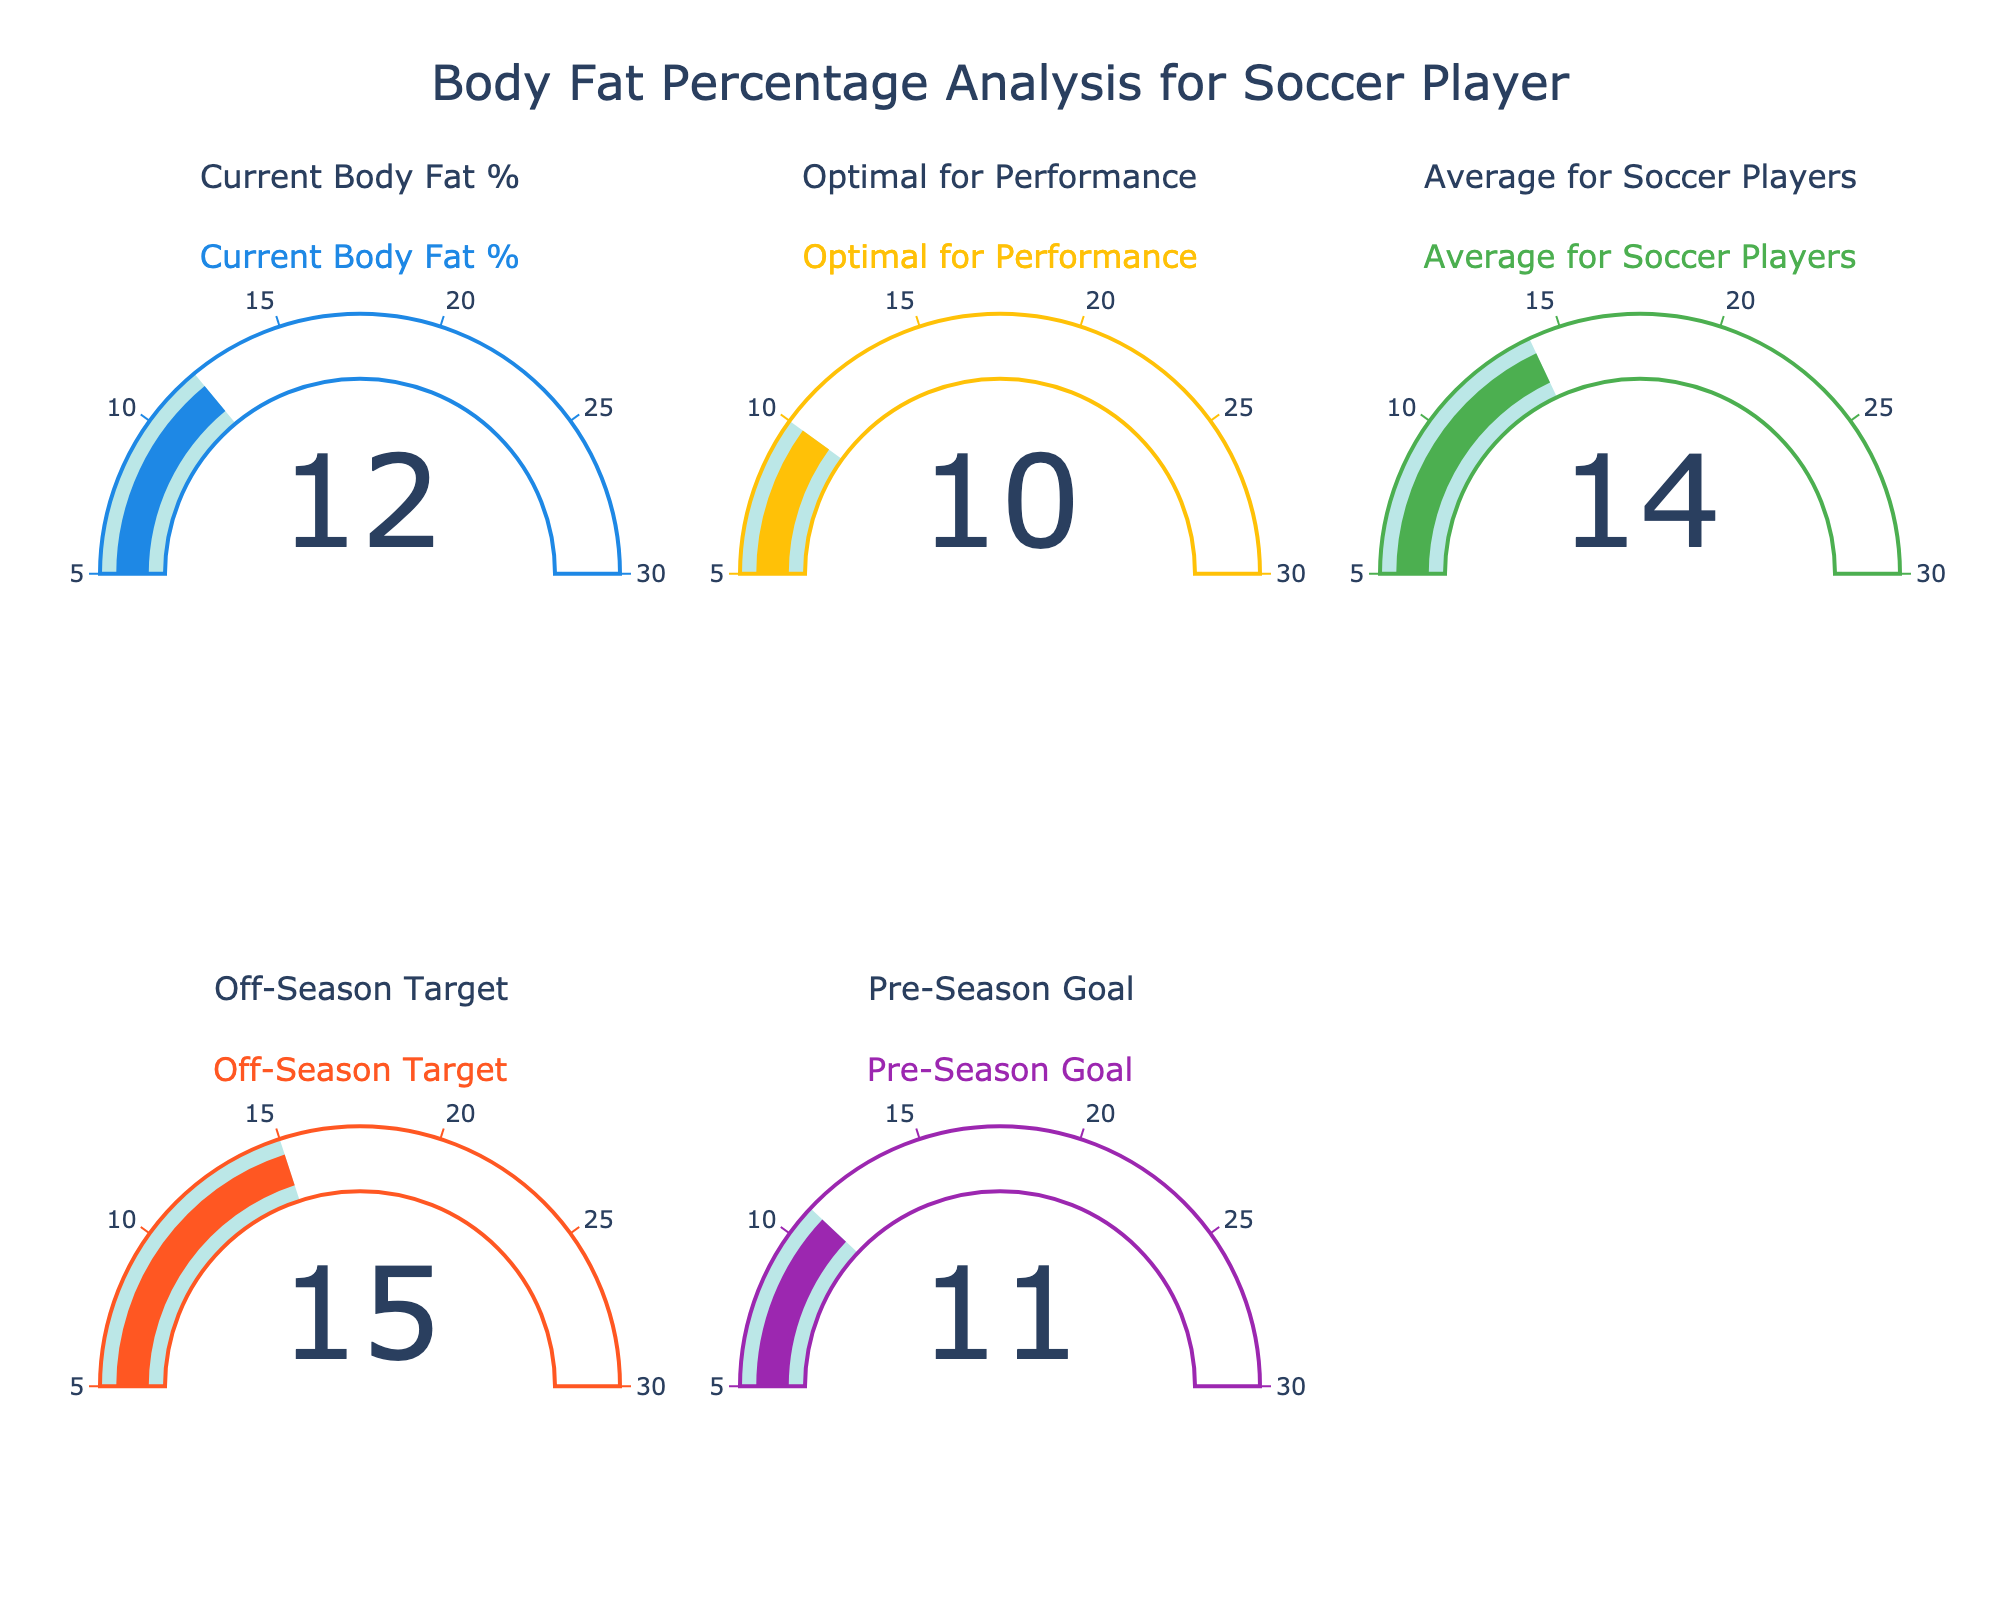What's the title of the figure? The title is typically displayed at the top of a figure or plot. In this case, it's mentioned in the code's update_layout function as "Body Fat Percentage Analysis for Soccer Player".
Answer: Body Fat Percentage Analysis for Soccer Player How many gauge charts are included in this figure? The subplot_spec lists 5 indicators: 3 in the first row and 2 in the second row. Counting each gauge chart displayed, we get 5.
Answer: 5 What is the current body fat percentage? The gauge chart labeled "Current Body Fat %" shows the value directly displayed as a number. Here it shows 12%.
Answer: 12% Which category has the highest value? Comparing the displayed numbers across all gauges, "Off-Season Target" has the highest value of 15%.
Answer: Off-Season Target What's the difference between the "Current Body Fat %" and "Pre-Season Goal"? Subtract the value of "Pre-Season Goal" (11%) from "Current Body Fat %" (12%).
Answer: 1% Which category has a lower body fat percentage, "Current Body Fat %" or "Average for Soccer Players"? Compare the values for these categories: "Current Body Fat %" is 12% and "Average for Soccer Players" is 14%. Since 12% < 14%, the current body fat percentage is lower.
Answer: Current Body Fat % What range is set for the gauges in the figure? The code mentions a consistent range for all gauges, from Min 5% to Max 30%.
Answer: 5-30% Are all displayed values within the specified range of the gauges? We must check if each value (12, 10, 14, 15, 11) falls between the range of 5 and 30. All of them fall within this range.
Answer: Yes How close is the "Optimal for Performance" value to the "Pre-Season Goal"? Compare the values directly: "Optimal for Performance" shows 10% while "Pre-Season Goal" shows 11%. The difference is 1%.
Answer: 1% 